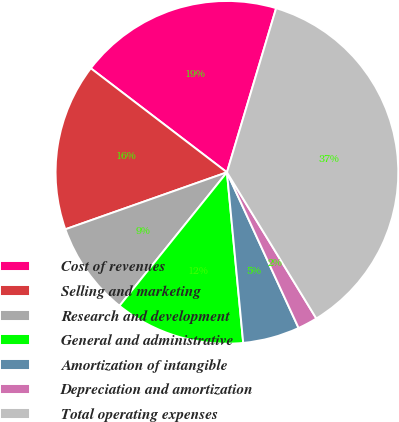Convert chart to OTSL. <chart><loc_0><loc_0><loc_500><loc_500><pie_chart><fcel>Cost of revenues<fcel>Selling and marketing<fcel>Research and development<fcel>General and administrative<fcel>Amortization of intangible<fcel>Depreciation and amortization<fcel>Total operating expenses<nl><fcel>19.25%<fcel>15.78%<fcel>8.82%<fcel>12.3%<fcel>5.35%<fcel>1.87%<fcel>36.63%<nl></chart> 